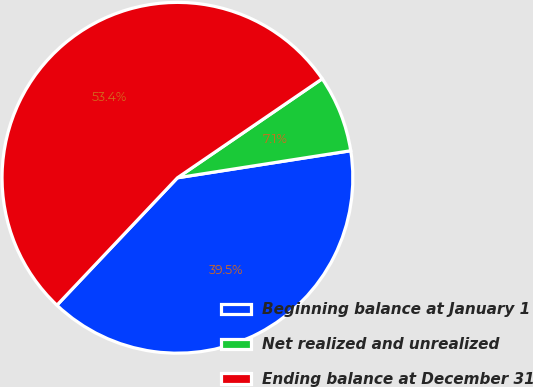Convert chart. <chart><loc_0><loc_0><loc_500><loc_500><pie_chart><fcel>Beginning balance at January 1<fcel>Net realized and unrealized<fcel>Ending balance at December 31<nl><fcel>39.52%<fcel>7.08%<fcel>53.39%<nl></chart> 